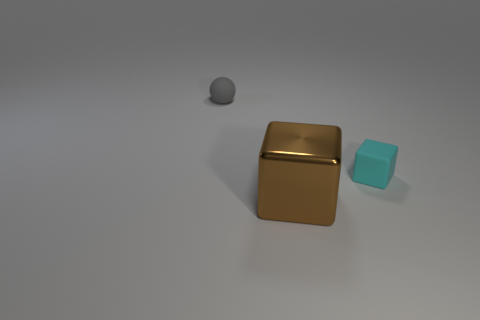What material is the thing that is both in front of the small matte ball and behind the large brown block?
Give a very brief answer. Rubber. There is a large metallic object; is its shape the same as the rubber object that is right of the tiny gray object?
Offer a terse response. Yes. The tiny object that is left of the large block in front of the gray thing left of the tiny matte cube is made of what material?
Offer a very short reply. Rubber. What number of other objects are the same size as the cyan rubber object?
Make the answer very short. 1. Do the matte cube and the small matte sphere have the same color?
Your response must be concise. No. How many tiny cyan blocks are right of the small thing that is in front of the matte object behind the small cyan matte block?
Ensure brevity in your answer.  0. There is a thing that is behind the small object on the right side of the big brown shiny thing; what is its material?
Make the answer very short. Rubber. Are there any big green rubber things of the same shape as the tiny cyan matte object?
Your answer should be very brief. No. There is a object that is the same size as the gray ball; what color is it?
Your answer should be compact. Cyan. What number of things are either rubber things on the left side of the big object or tiny rubber things that are on the left side of the brown metallic block?
Provide a short and direct response. 1. 